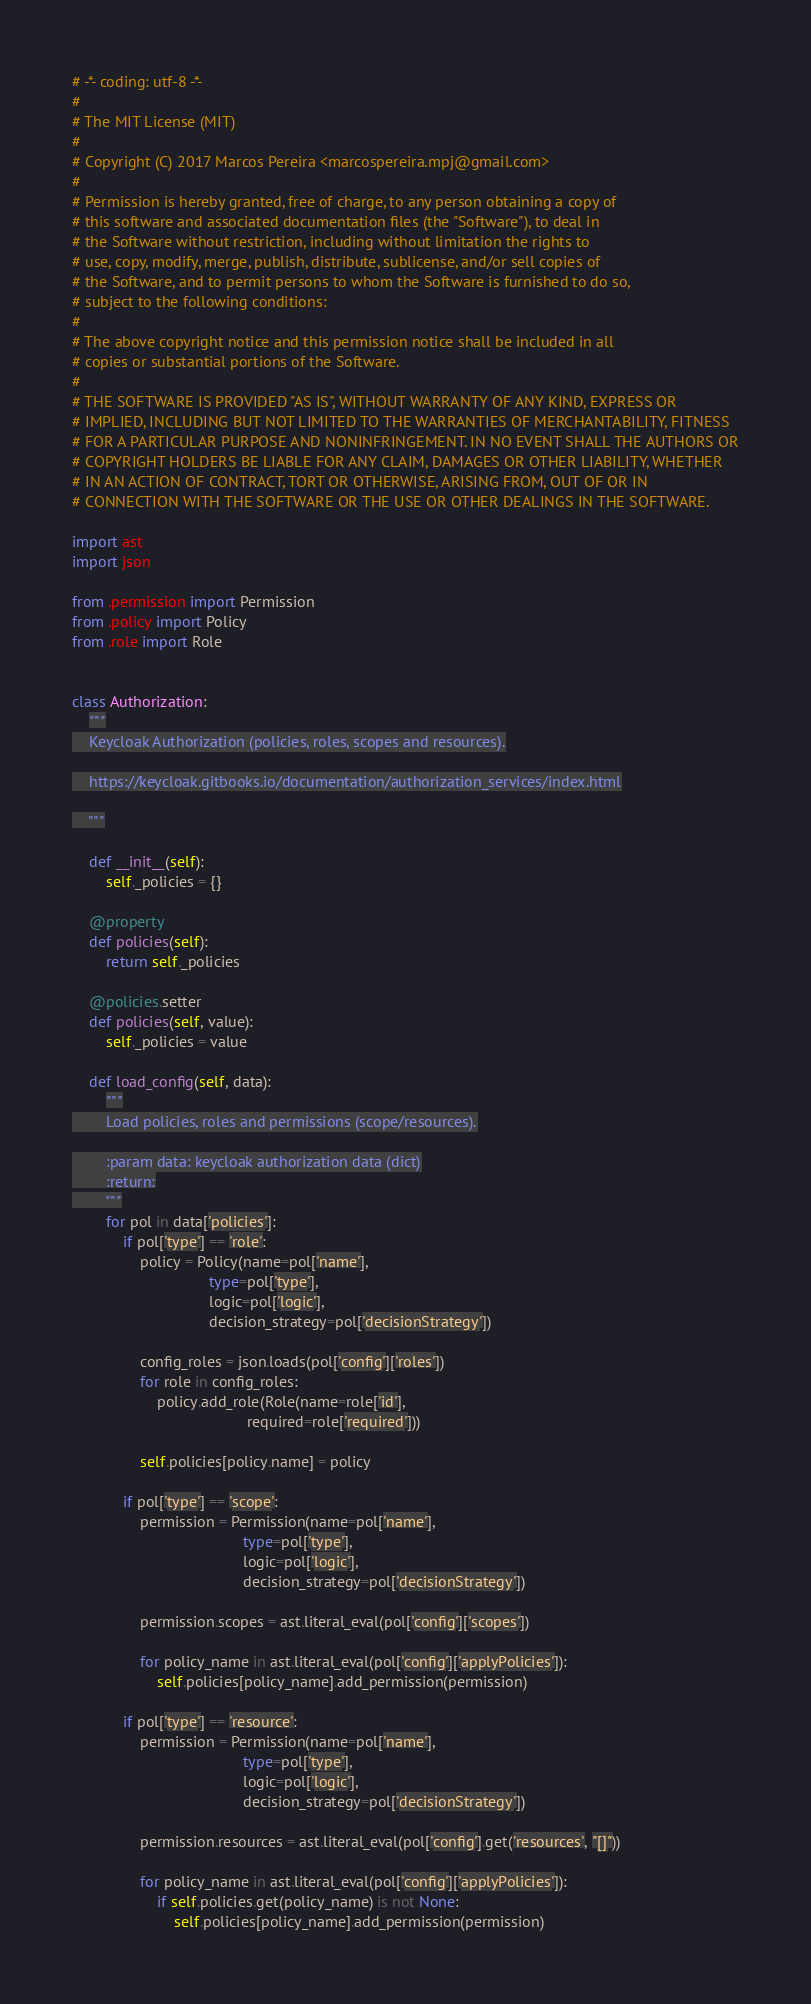<code> <loc_0><loc_0><loc_500><loc_500><_Python_># -*- coding: utf-8 -*-
#
# The MIT License (MIT)
#
# Copyright (C) 2017 Marcos Pereira <marcospereira.mpj@gmail.com>
#
# Permission is hereby granted, free of charge, to any person obtaining a copy of
# this software and associated documentation files (the "Software"), to deal in
# the Software without restriction, including without limitation the rights to
# use, copy, modify, merge, publish, distribute, sublicense, and/or sell copies of
# the Software, and to permit persons to whom the Software is furnished to do so,
# subject to the following conditions:
#
# The above copyright notice and this permission notice shall be included in all
# copies or substantial portions of the Software.
#
# THE SOFTWARE IS PROVIDED "AS IS", WITHOUT WARRANTY OF ANY KIND, EXPRESS OR
# IMPLIED, INCLUDING BUT NOT LIMITED TO THE WARRANTIES OF MERCHANTABILITY, FITNESS
# FOR A PARTICULAR PURPOSE AND NONINFRINGEMENT. IN NO EVENT SHALL THE AUTHORS OR
# COPYRIGHT HOLDERS BE LIABLE FOR ANY CLAIM, DAMAGES OR OTHER LIABILITY, WHETHER
# IN AN ACTION OF CONTRACT, TORT OR OTHERWISE, ARISING FROM, OUT OF OR IN
# CONNECTION WITH THE SOFTWARE OR THE USE OR OTHER DEALINGS IN THE SOFTWARE.

import ast
import json

from .permission import Permission
from .policy import Policy
from .role import Role


class Authorization:
    """
    Keycloak Authorization (policies, roles, scopes and resources).

    https://keycloak.gitbooks.io/documentation/authorization_services/index.html

    """

    def __init__(self):
        self._policies = {}

    @property
    def policies(self):
        return self._policies

    @policies.setter
    def policies(self, value):
        self._policies = value

    def load_config(self, data):
        """
        Load policies, roles and permissions (scope/resources).

        :param data: keycloak authorization data (dict)
        :return:
        """
        for pol in data['policies']:
            if pol['type'] == 'role':
                policy = Policy(name=pol['name'],
                                type=pol['type'],
                                logic=pol['logic'],
                                decision_strategy=pol['decisionStrategy'])

                config_roles = json.loads(pol['config']['roles'])
                for role in config_roles:
                    policy.add_role(Role(name=role['id'],
                                         required=role['required']))

                self.policies[policy.name] = policy

            if pol['type'] == 'scope':
                permission = Permission(name=pol['name'],
                                        type=pol['type'],
                                        logic=pol['logic'],
                                        decision_strategy=pol['decisionStrategy'])

                permission.scopes = ast.literal_eval(pol['config']['scopes'])

                for policy_name in ast.literal_eval(pol['config']['applyPolicies']):
                    self.policies[policy_name].add_permission(permission)

            if pol['type'] == 'resource':
                permission = Permission(name=pol['name'],
                                        type=pol['type'],
                                        logic=pol['logic'],
                                        decision_strategy=pol['decisionStrategy'])

                permission.resources = ast.literal_eval(pol['config'].get('resources', "[]"))

                for policy_name in ast.literal_eval(pol['config']['applyPolicies']):
                    if self.policies.get(policy_name) is not None:
                        self.policies[policy_name].add_permission(permission)
</code> 